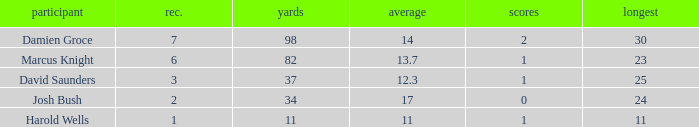How many TDs are there were the long is smaller than 23? 1.0. 